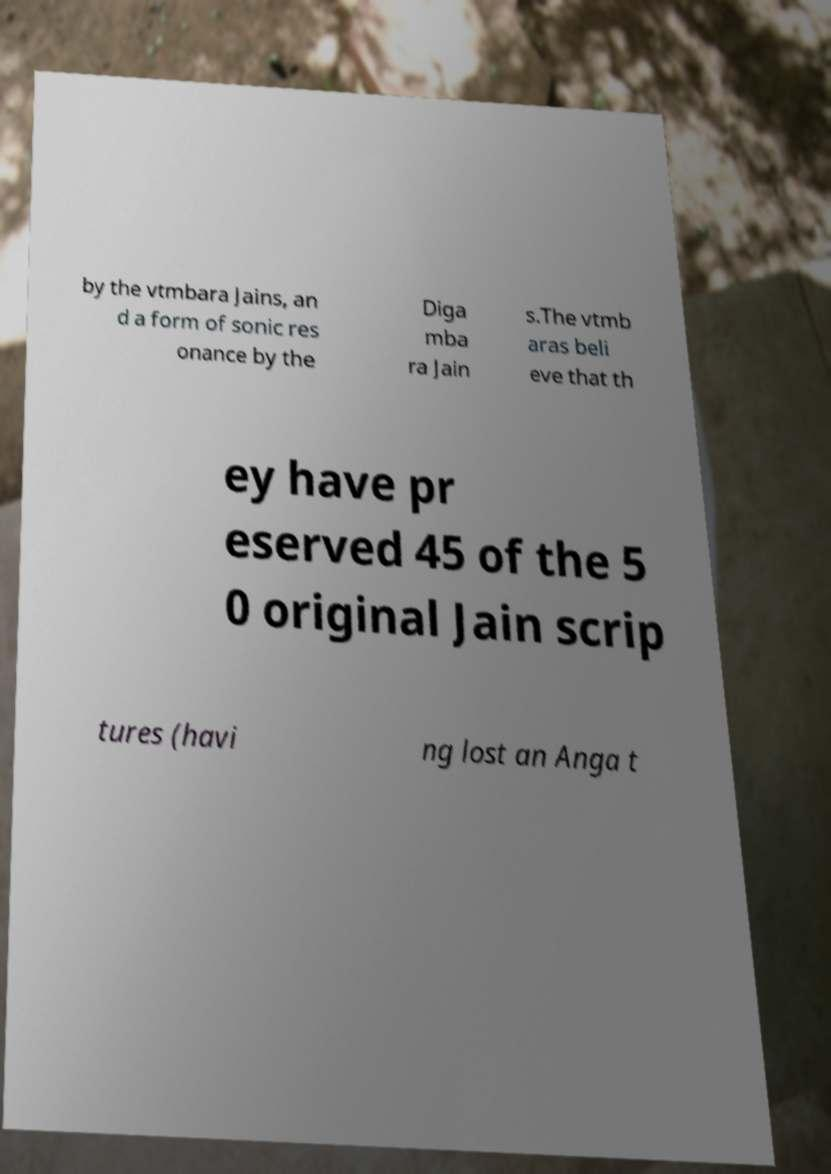For documentation purposes, I need the text within this image transcribed. Could you provide that? by the vtmbara Jains, an d a form of sonic res onance by the Diga mba ra Jain s.The vtmb aras beli eve that th ey have pr eserved 45 of the 5 0 original Jain scrip tures (havi ng lost an Anga t 